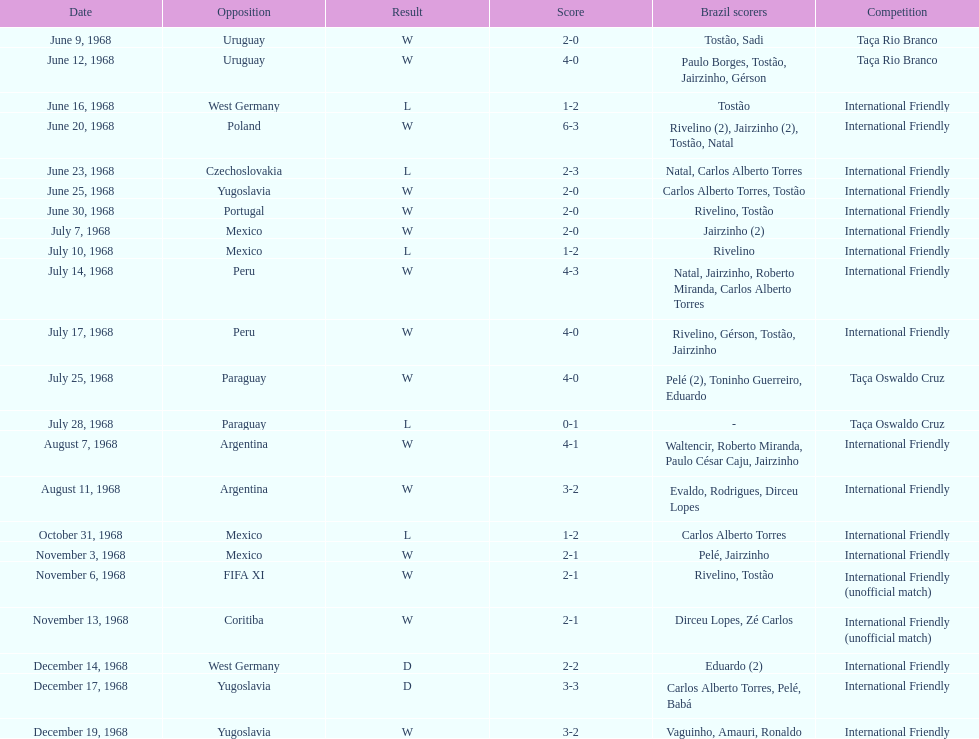What is the number of matches won? 15. 